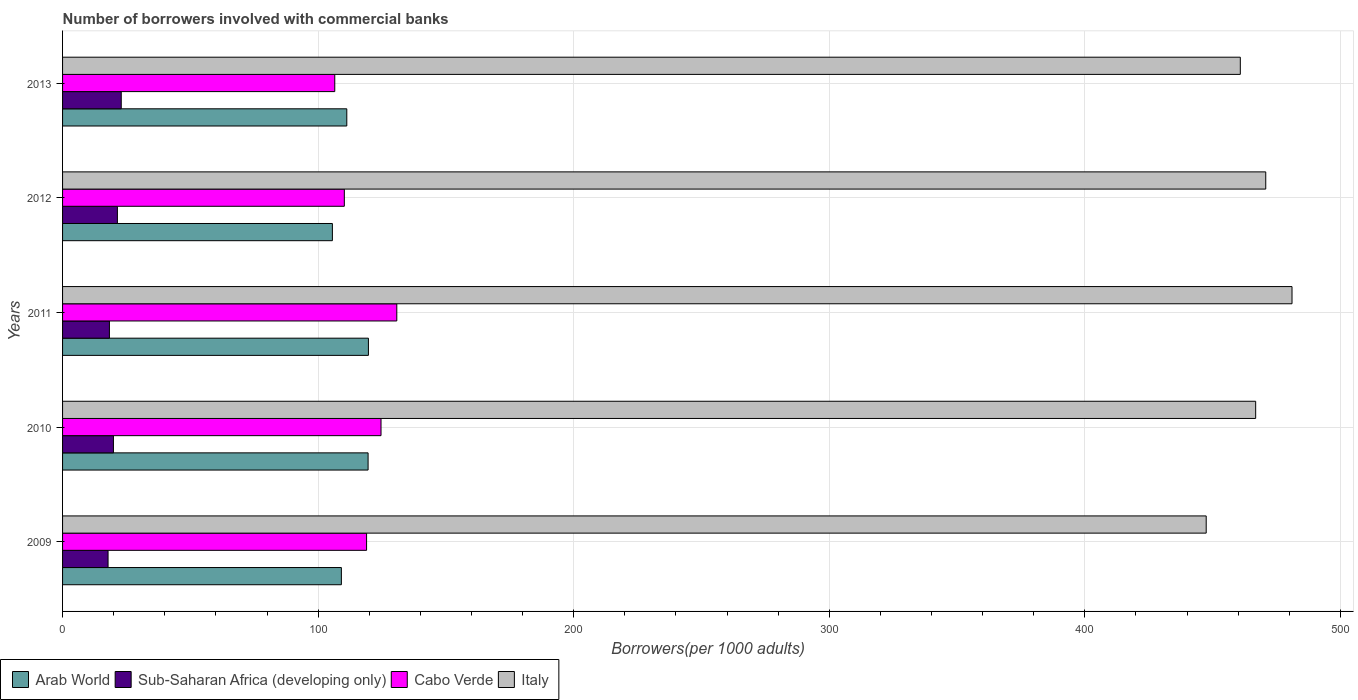How many groups of bars are there?
Ensure brevity in your answer.  5. Are the number of bars on each tick of the Y-axis equal?
Offer a very short reply. Yes. How many bars are there on the 4th tick from the bottom?
Make the answer very short. 4. In how many cases, is the number of bars for a given year not equal to the number of legend labels?
Provide a succinct answer. 0. What is the number of borrowers involved with commercial banks in Italy in 2011?
Provide a succinct answer. 481.07. Across all years, what is the maximum number of borrowers involved with commercial banks in Italy?
Your answer should be very brief. 481.07. Across all years, what is the minimum number of borrowers involved with commercial banks in Cabo Verde?
Provide a short and direct response. 106.51. In which year was the number of borrowers involved with commercial banks in Sub-Saharan Africa (developing only) minimum?
Give a very brief answer. 2009. What is the total number of borrowers involved with commercial banks in Sub-Saharan Africa (developing only) in the graph?
Ensure brevity in your answer.  100.46. What is the difference between the number of borrowers involved with commercial banks in Cabo Verde in 2010 and that in 2011?
Offer a terse response. -6.18. What is the difference between the number of borrowers involved with commercial banks in Sub-Saharan Africa (developing only) in 2009 and the number of borrowers involved with commercial banks in Italy in 2012?
Provide a short and direct response. -452.98. What is the average number of borrowers involved with commercial banks in Arab World per year?
Offer a terse response. 113.02. In the year 2012, what is the difference between the number of borrowers involved with commercial banks in Arab World and number of borrowers involved with commercial banks in Italy?
Give a very brief answer. -365.21. What is the ratio of the number of borrowers involved with commercial banks in Sub-Saharan Africa (developing only) in 2010 to that in 2011?
Keep it short and to the point. 1.09. Is the difference between the number of borrowers involved with commercial banks in Arab World in 2009 and 2012 greater than the difference between the number of borrowers involved with commercial banks in Italy in 2009 and 2012?
Your answer should be compact. Yes. What is the difference between the highest and the second highest number of borrowers involved with commercial banks in Italy?
Give a very brief answer. 10.28. What is the difference between the highest and the lowest number of borrowers involved with commercial banks in Arab World?
Your response must be concise. 14.1. What does the 2nd bar from the top in 2011 represents?
Ensure brevity in your answer.  Cabo Verde. How many bars are there?
Offer a very short reply. 20. Does the graph contain grids?
Give a very brief answer. Yes. How are the legend labels stacked?
Provide a succinct answer. Horizontal. What is the title of the graph?
Your response must be concise. Number of borrowers involved with commercial banks. Does "Botswana" appear as one of the legend labels in the graph?
Offer a very short reply. No. What is the label or title of the X-axis?
Offer a very short reply. Borrowers(per 1000 adults). What is the label or title of the Y-axis?
Offer a terse response. Years. What is the Borrowers(per 1000 adults) of Arab World in 2009?
Offer a terse response. 109.1. What is the Borrowers(per 1000 adults) in Sub-Saharan Africa (developing only) in 2009?
Provide a short and direct response. 17.81. What is the Borrowers(per 1000 adults) of Cabo Verde in 2009?
Provide a short and direct response. 118.96. What is the Borrowers(per 1000 adults) in Italy in 2009?
Offer a very short reply. 447.49. What is the Borrowers(per 1000 adults) of Arab World in 2010?
Keep it short and to the point. 119.55. What is the Borrowers(per 1000 adults) of Sub-Saharan Africa (developing only) in 2010?
Keep it short and to the point. 19.9. What is the Borrowers(per 1000 adults) of Cabo Verde in 2010?
Your answer should be compact. 124.61. What is the Borrowers(per 1000 adults) in Italy in 2010?
Your answer should be very brief. 466.85. What is the Borrowers(per 1000 adults) in Arab World in 2011?
Give a very brief answer. 119.68. What is the Borrowers(per 1000 adults) in Sub-Saharan Africa (developing only) in 2011?
Provide a short and direct response. 18.33. What is the Borrowers(per 1000 adults) in Cabo Verde in 2011?
Make the answer very short. 130.78. What is the Borrowers(per 1000 adults) of Italy in 2011?
Give a very brief answer. 481.07. What is the Borrowers(per 1000 adults) of Arab World in 2012?
Keep it short and to the point. 105.58. What is the Borrowers(per 1000 adults) in Sub-Saharan Africa (developing only) in 2012?
Your answer should be compact. 21.46. What is the Borrowers(per 1000 adults) of Cabo Verde in 2012?
Your answer should be compact. 110.25. What is the Borrowers(per 1000 adults) of Italy in 2012?
Your answer should be very brief. 470.79. What is the Borrowers(per 1000 adults) in Arab World in 2013?
Provide a short and direct response. 111.22. What is the Borrowers(per 1000 adults) of Sub-Saharan Africa (developing only) in 2013?
Make the answer very short. 22.96. What is the Borrowers(per 1000 adults) in Cabo Verde in 2013?
Give a very brief answer. 106.51. What is the Borrowers(per 1000 adults) of Italy in 2013?
Ensure brevity in your answer.  460.84. Across all years, what is the maximum Borrowers(per 1000 adults) in Arab World?
Your answer should be very brief. 119.68. Across all years, what is the maximum Borrowers(per 1000 adults) in Sub-Saharan Africa (developing only)?
Your answer should be very brief. 22.96. Across all years, what is the maximum Borrowers(per 1000 adults) of Cabo Verde?
Your response must be concise. 130.78. Across all years, what is the maximum Borrowers(per 1000 adults) in Italy?
Give a very brief answer. 481.07. Across all years, what is the minimum Borrowers(per 1000 adults) of Arab World?
Ensure brevity in your answer.  105.58. Across all years, what is the minimum Borrowers(per 1000 adults) in Sub-Saharan Africa (developing only)?
Ensure brevity in your answer.  17.81. Across all years, what is the minimum Borrowers(per 1000 adults) of Cabo Verde?
Offer a terse response. 106.51. Across all years, what is the minimum Borrowers(per 1000 adults) of Italy?
Keep it short and to the point. 447.49. What is the total Borrowers(per 1000 adults) in Arab World in the graph?
Provide a succinct answer. 565.12. What is the total Borrowers(per 1000 adults) of Sub-Saharan Africa (developing only) in the graph?
Provide a succinct answer. 100.46. What is the total Borrowers(per 1000 adults) of Cabo Verde in the graph?
Give a very brief answer. 591.11. What is the total Borrowers(per 1000 adults) of Italy in the graph?
Your answer should be very brief. 2327.04. What is the difference between the Borrowers(per 1000 adults) of Arab World in 2009 and that in 2010?
Keep it short and to the point. -10.45. What is the difference between the Borrowers(per 1000 adults) in Sub-Saharan Africa (developing only) in 2009 and that in 2010?
Keep it short and to the point. -2.1. What is the difference between the Borrowers(per 1000 adults) of Cabo Verde in 2009 and that in 2010?
Make the answer very short. -5.65. What is the difference between the Borrowers(per 1000 adults) in Italy in 2009 and that in 2010?
Your response must be concise. -19.36. What is the difference between the Borrowers(per 1000 adults) of Arab World in 2009 and that in 2011?
Your answer should be very brief. -10.58. What is the difference between the Borrowers(per 1000 adults) of Sub-Saharan Africa (developing only) in 2009 and that in 2011?
Your response must be concise. -0.53. What is the difference between the Borrowers(per 1000 adults) of Cabo Verde in 2009 and that in 2011?
Your answer should be compact. -11.82. What is the difference between the Borrowers(per 1000 adults) in Italy in 2009 and that in 2011?
Make the answer very short. -33.58. What is the difference between the Borrowers(per 1000 adults) of Arab World in 2009 and that in 2012?
Keep it short and to the point. 3.52. What is the difference between the Borrowers(per 1000 adults) of Sub-Saharan Africa (developing only) in 2009 and that in 2012?
Keep it short and to the point. -3.65. What is the difference between the Borrowers(per 1000 adults) of Cabo Verde in 2009 and that in 2012?
Ensure brevity in your answer.  8.71. What is the difference between the Borrowers(per 1000 adults) of Italy in 2009 and that in 2012?
Give a very brief answer. -23.3. What is the difference between the Borrowers(per 1000 adults) of Arab World in 2009 and that in 2013?
Provide a short and direct response. -2.12. What is the difference between the Borrowers(per 1000 adults) of Sub-Saharan Africa (developing only) in 2009 and that in 2013?
Keep it short and to the point. -5.16. What is the difference between the Borrowers(per 1000 adults) of Cabo Verde in 2009 and that in 2013?
Provide a short and direct response. 12.45. What is the difference between the Borrowers(per 1000 adults) in Italy in 2009 and that in 2013?
Ensure brevity in your answer.  -13.35. What is the difference between the Borrowers(per 1000 adults) of Arab World in 2010 and that in 2011?
Keep it short and to the point. -0.13. What is the difference between the Borrowers(per 1000 adults) in Sub-Saharan Africa (developing only) in 2010 and that in 2011?
Offer a very short reply. 1.57. What is the difference between the Borrowers(per 1000 adults) of Cabo Verde in 2010 and that in 2011?
Your answer should be compact. -6.18. What is the difference between the Borrowers(per 1000 adults) of Italy in 2010 and that in 2011?
Offer a terse response. -14.22. What is the difference between the Borrowers(per 1000 adults) in Arab World in 2010 and that in 2012?
Your response must be concise. 13.97. What is the difference between the Borrowers(per 1000 adults) in Sub-Saharan Africa (developing only) in 2010 and that in 2012?
Provide a succinct answer. -1.56. What is the difference between the Borrowers(per 1000 adults) of Cabo Verde in 2010 and that in 2012?
Keep it short and to the point. 14.36. What is the difference between the Borrowers(per 1000 adults) of Italy in 2010 and that in 2012?
Offer a terse response. -3.94. What is the difference between the Borrowers(per 1000 adults) of Arab World in 2010 and that in 2013?
Make the answer very short. 8.33. What is the difference between the Borrowers(per 1000 adults) in Sub-Saharan Africa (developing only) in 2010 and that in 2013?
Keep it short and to the point. -3.06. What is the difference between the Borrowers(per 1000 adults) in Cabo Verde in 2010 and that in 2013?
Make the answer very short. 18.1. What is the difference between the Borrowers(per 1000 adults) in Italy in 2010 and that in 2013?
Your answer should be compact. 6.01. What is the difference between the Borrowers(per 1000 adults) of Arab World in 2011 and that in 2012?
Keep it short and to the point. 14.1. What is the difference between the Borrowers(per 1000 adults) in Sub-Saharan Africa (developing only) in 2011 and that in 2012?
Your answer should be very brief. -3.13. What is the difference between the Borrowers(per 1000 adults) in Cabo Verde in 2011 and that in 2012?
Ensure brevity in your answer.  20.53. What is the difference between the Borrowers(per 1000 adults) of Italy in 2011 and that in 2012?
Give a very brief answer. 10.28. What is the difference between the Borrowers(per 1000 adults) in Arab World in 2011 and that in 2013?
Offer a terse response. 8.46. What is the difference between the Borrowers(per 1000 adults) of Sub-Saharan Africa (developing only) in 2011 and that in 2013?
Provide a succinct answer. -4.63. What is the difference between the Borrowers(per 1000 adults) of Cabo Verde in 2011 and that in 2013?
Your answer should be very brief. 24.27. What is the difference between the Borrowers(per 1000 adults) in Italy in 2011 and that in 2013?
Provide a short and direct response. 20.23. What is the difference between the Borrowers(per 1000 adults) in Arab World in 2012 and that in 2013?
Keep it short and to the point. -5.64. What is the difference between the Borrowers(per 1000 adults) in Sub-Saharan Africa (developing only) in 2012 and that in 2013?
Your answer should be compact. -1.5. What is the difference between the Borrowers(per 1000 adults) in Cabo Verde in 2012 and that in 2013?
Make the answer very short. 3.74. What is the difference between the Borrowers(per 1000 adults) of Italy in 2012 and that in 2013?
Offer a terse response. 9.95. What is the difference between the Borrowers(per 1000 adults) of Arab World in 2009 and the Borrowers(per 1000 adults) of Sub-Saharan Africa (developing only) in 2010?
Give a very brief answer. 89.19. What is the difference between the Borrowers(per 1000 adults) in Arab World in 2009 and the Borrowers(per 1000 adults) in Cabo Verde in 2010?
Offer a terse response. -15.51. What is the difference between the Borrowers(per 1000 adults) of Arab World in 2009 and the Borrowers(per 1000 adults) of Italy in 2010?
Your answer should be very brief. -357.75. What is the difference between the Borrowers(per 1000 adults) of Sub-Saharan Africa (developing only) in 2009 and the Borrowers(per 1000 adults) of Cabo Verde in 2010?
Provide a short and direct response. -106.8. What is the difference between the Borrowers(per 1000 adults) of Sub-Saharan Africa (developing only) in 2009 and the Borrowers(per 1000 adults) of Italy in 2010?
Provide a short and direct response. -449.05. What is the difference between the Borrowers(per 1000 adults) of Cabo Verde in 2009 and the Borrowers(per 1000 adults) of Italy in 2010?
Ensure brevity in your answer.  -347.89. What is the difference between the Borrowers(per 1000 adults) in Arab World in 2009 and the Borrowers(per 1000 adults) in Sub-Saharan Africa (developing only) in 2011?
Your answer should be very brief. 90.77. What is the difference between the Borrowers(per 1000 adults) in Arab World in 2009 and the Borrowers(per 1000 adults) in Cabo Verde in 2011?
Give a very brief answer. -21.69. What is the difference between the Borrowers(per 1000 adults) in Arab World in 2009 and the Borrowers(per 1000 adults) in Italy in 2011?
Provide a short and direct response. -371.97. What is the difference between the Borrowers(per 1000 adults) of Sub-Saharan Africa (developing only) in 2009 and the Borrowers(per 1000 adults) of Cabo Verde in 2011?
Offer a terse response. -112.98. What is the difference between the Borrowers(per 1000 adults) in Sub-Saharan Africa (developing only) in 2009 and the Borrowers(per 1000 adults) in Italy in 2011?
Offer a terse response. -463.27. What is the difference between the Borrowers(per 1000 adults) of Cabo Verde in 2009 and the Borrowers(per 1000 adults) of Italy in 2011?
Provide a succinct answer. -362.11. What is the difference between the Borrowers(per 1000 adults) in Arab World in 2009 and the Borrowers(per 1000 adults) in Sub-Saharan Africa (developing only) in 2012?
Your answer should be very brief. 87.64. What is the difference between the Borrowers(per 1000 adults) in Arab World in 2009 and the Borrowers(per 1000 adults) in Cabo Verde in 2012?
Give a very brief answer. -1.15. What is the difference between the Borrowers(per 1000 adults) of Arab World in 2009 and the Borrowers(per 1000 adults) of Italy in 2012?
Your answer should be very brief. -361.69. What is the difference between the Borrowers(per 1000 adults) in Sub-Saharan Africa (developing only) in 2009 and the Borrowers(per 1000 adults) in Cabo Verde in 2012?
Ensure brevity in your answer.  -92.45. What is the difference between the Borrowers(per 1000 adults) of Sub-Saharan Africa (developing only) in 2009 and the Borrowers(per 1000 adults) of Italy in 2012?
Give a very brief answer. -452.98. What is the difference between the Borrowers(per 1000 adults) in Cabo Verde in 2009 and the Borrowers(per 1000 adults) in Italy in 2012?
Give a very brief answer. -351.83. What is the difference between the Borrowers(per 1000 adults) in Arab World in 2009 and the Borrowers(per 1000 adults) in Sub-Saharan Africa (developing only) in 2013?
Make the answer very short. 86.13. What is the difference between the Borrowers(per 1000 adults) in Arab World in 2009 and the Borrowers(per 1000 adults) in Cabo Verde in 2013?
Give a very brief answer. 2.59. What is the difference between the Borrowers(per 1000 adults) of Arab World in 2009 and the Borrowers(per 1000 adults) of Italy in 2013?
Keep it short and to the point. -351.74. What is the difference between the Borrowers(per 1000 adults) of Sub-Saharan Africa (developing only) in 2009 and the Borrowers(per 1000 adults) of Cabo Verde in 2013?
Provide a short and direct response. -88.7. What is the difference between the Borrowers(per 1000 adults) of Sub-Saharan Africa (developing only) in 2009 and the Borrowers(per 1000 adults) of Italy in 2013?
Keep it short and to the point. -443.04. What is the difference between the Borrowers(per 1000 adults) of Cabo Verde in 2009 and the Borrowers(per 1000 adults) of Italy in 2013?
Make the answer very short. -341.88. What is the difference between the Borrowers(per 1000 adults) of Arab World in 2010 and the Borrowers(per 1000 adults) of Sub-Saharan Africa (developing only) in 2011?
Keep it short and to the point. 101.22. What is the difference between the Borrowers(per 1000 adults) of Arab World in 2010 and the Borrowers(per 1000 adults) of Cabo Verde in 2011?
Your answer should be compact. -11.23. What is the difference between the Borrowers(per 1000 adults) of Arab World in 2010 and the Borrowers(per 1000 adults) of Italy in 2011?
Provide a succinct answer. -361.52. What is the difference between the Borrowers(per 1000 adults) in Sub-Saharan Africa (developing only) in 2010 and the Borrowers(per 1000 adults) in Cabo Verde in 2011?
Ensure brevity in your answer.  -110.88. What is the difference between the Borrowers(per 1000 adults) in Sub-Saharan Africa (developing only) in 2010 and the Borrowers(per 1000 adults) in Italy in 2011?
Offer a terse response. -461.17. What is the difference between the Borrowers(per 1000 adults) in Cabo Verde in 2010 and the Borrowers(per 1000 adults) in Italy in 2011?
Give a very brief answer. -356.46. What is the difference between the Borrowers(per 1000 adults) of Arab World in 2010 and the Borrowers(per 1000 adults) of Sub-Saharan Africa (developing only) in 2012?
Give a very brief answer. 98.09. What is the difference between the Borrowers(per 1000 adults) of Arab World in 2010 and the Borrowers(per 1000 adults) of Cabo Verde in 2012?
Offer a very short reply. 9.3. What is the difference between the Borrowers(per 1000 adults) in Arab World in 2010 and the Borrowers(per 1000 adults) in Italy in 2012?
Keep it short and to the point. -351.24. What is the difference between the Borrowers(per 1000 adults) of Sub-Saharan Africa (developing only) in 2010 and the Borrowers(per 1000 adults) of Cabo Verde in 2012?
Provide a short and direct response. -90.35. What is the difference between the Borrowers(per 1000 adults) of Sub-Saharan Africa (developing only) in 2010 and the Borrowers(per 1000 adults) of Italy in 2012?
Your answer should be very brief. -450.89. What is the difference between the Borrowers(per 1000 adults) in Cabo Verde in 2010 and the Borrowers(per 1000 adults) in Italy in 2012?
Offer a terse response. -346.18. What is the difference between the Borrowers(per 1000 adults) in Arab World in 2010 and the Borrowers(per 1000 adults) in Sub-Saharan Africa (developing only) in 2013?
Your answer should be very brief. 96.59. What is the difference between the Borrowers(per 1000 adults) of Arab World in 2010 and the Borrowers(per 1000 adults) of Cabo Verde in 2013?
Make the answer very short. 13.04. What is the difference between the Borrowers(per 1000 adults) in Arab World in 2010 and the Borrowers(per 1000 adults) in Italy in 2013?
Provide a succinct answer. -341.29. What is the difference between the Borrowers(per 1000 adults) in Sub-Saharan Africa (developing only) in 2010 and the Borrowers(per 1000 adults) in Cabo Verde in 2013?
Your answer should be compact. -86.6. What is the difference between the Borrowers(per 1000 adults) in Sub-Saharan Africa (developing only) in 2010 and the Borrowers(per 1000 adults) in Italy in 2013?
Provide a succinct answer. -440.94. What is the difference between the Borrowers(per 1000 adults) of Cabo Verde in 2010 and the Borrowers(per 1000 adults) of Italy in 2013?
Your answer should be compact. -336.23. What is the difference between the Borrowers(per 1000 adults) of Arab World in 2011 and the Borrowers(per 1000 adults) of Sub-Saharan Africa (developing only) in 2012?
Keep it short and to the point. 98.22. What is the difference between the Borrowers(per 1000 adults) of Arab World in 2011 and the Borrowers(per 1000 adults) of Cabo Verde in 2012?
Provide a short and direct response. 9.43. What is the difference between the Borrowers(per 1000 adults) of Arab World in 2011 and the Borrowers(per 1000 adults) of Italy in 2012?
Keep it short and to the point. -351.11. What is the difference between the Borrowers(per 1000 adults) of Sub-Saharan Africa (developing only) in 2011 and the Borrowers(per 1000 adults) of Cabo Verde in 2012?
Make the answer very short. -91.92. What is the difference between the Borrowers(per 1000 adults) in Sub-Saharan Africa (developing only) in 2011 and the Borrowers(per 1000 adults) in Italy in 2012?
Offer a terse response. -452.46. What is the difference between the Borrowers(per 1000 adults) of Cabo Verde in 2011 and the Borrowers(per 1000 adults) of Italy in 2012?
Provide a short and direct response. -340.01. What is the difference between the Borrowers(per 1000 adults) in Arab World in 2011 and the Borrowers(per 1000 adults) in Sub-Saharan Africa (developing only) in 2013?
Offer a very short reply. 96.72. What is the difference between the Borrowers(per 1000 adults) in Arab World in 2011 and the Borrowers(per 1000 adults) in Cabo Verde in 2013?
Give a very brief answer. 13.17. What is the difference between the Borrowers(per 1000 adults) of Arab World in 2011 and the Borrowers(per 1000 adults) of Italy in 2013?
Your answer should be compact. -341.16. What is the difference between the Borrowers(per 1000 adults) of Sub-Saharan Africa (developing only) in 2011 and the Borrowers(per 1000 adults) of Cabo Verde in 2013?
Keep it short and to the point. -88.18. What is the difference between the Borrowers(per 1000 adults) in Sub-Saharan Africa (developing only) in 2011 and the Borrowers(per 1000 adults) in Italy in 2013?
Ensure brevity in your answer.  -442.51. What is the difference between the Borrowers(per 1000 adults) of Cabo Verde in 2011 and the Borrowers(per 1000 adults) of Italy in 2013?
Ensure brevity in your answer.  -330.06. What is the difference between the Borrowers(per 1000 adults) of Arab World in 2012 and the Borrowers(per 1000 adults) of Sub-Saharan Africa (developing only) in 2013?
Make the answer very short. 82.62. What is the difference between the Borrowers(per 1000 adults) of Arab World in 2012 and the Borrowers(per 1000 adults) of Cabo Verde in 2013?
Offer a terse response. -0.93. What is the difference between the Borrowers(per 1000 adults) in Arab World in 2012 and the Borrowers(per 1000 adults) in Italy in 2013?
Provide a succinct answer. -355.26. What is the difference between the Borrowers(per 1000 adults) of Sub-Saharan Africa (developing only) in 2012 and the Borrowers(per 1000 adults) of Cabo Verde in 2013?
Your answer should be very brief. -85.05. What is the difference between the Borrowers(per 1000 adults) in Sub-Saharan Africa (developing only) in 2012 and the Borrowers(per 1000 adults) in Italy in 2013?
Your response must be concise. -439.38. What is the difference between the Borrowers(per 1000 adults) in Cabo Verde in 2012 and the Borrowers(per 1000 adults) in Italy in 2013?
Your answer should be very brief. -350.59. What is the average Borrowers(per 1000 adults) of Arab World per year?
Offer a terse response. 113.02. What is the average Borrowers(per 1000 adults) of Sub-Saharan Africa (developing only) per year?
Make the answer very short. 20.09. What is the average Borrowers(per 1000 adults) in Cabo Verde per year?
Give a very brief answer. 118.22. What is the average Borrowers(per 1000 adults) of Italy per year?
Your response must be concise. 465.41. In the year 2009, what is the difference between the Borrowers(per 1000 adults) in Arab World and Borrowers(per 1000 adults) in Sub-Saharan Africa (developing only)?
Provide a short and direct response. 91.29. In the year 2009, what is the difference between the Borrowers(per 1000 adults) of Arab World and Borrowers(per 1000 adults) of Cabo Verde?
Offer a terse response. -9.86. In the year 2009, what is the difference between the Borrowers(per 1000 adults) in Arab World and Borrowers(per 1000 adults) in Italy?
Provide a short and direct response. -338.39. In the year 2009, what is the difference between the Borrowers(per 1000 adults) in Sub-Saharan Africa (developing only) and Borrowers(per 1000 adults) in Cabo Verde?
Your answer should be very brief. -101.15. In the year 2009, what is the difference between the Borrowers(per 1000 adults) of Sub-Saharan Africa (developing only) and Borrowers(per 1000 adults) of Italy?
Keep it short and to the point. -429.68. In the year 2009, what is the difference between the Borrowers(per 1000 adults) in Cabo Verde and Borrowers(per 1000 adults) in Italy?
Offer a very short reply. -328.53. In the year 2010, what is the difference between the Borrowers(per 1000 adults) in Arab World and Borrowers(per 1000 adults) in Sub-Saharan Africa (developing only)?
Your response must be concise. 99.65. In the year 2010, what is the difference between the Borrowers(per 1000 adults) in Arab World and Borrowers(per 1000 adults) in Cabo Verde?
Offer a very short reply. -5.06. In the year 2010, what is the difference between the Borrowers(per 1000 adults) in Arab World and Borrowers(per 1000 adults) in Italy?
Ensure brevity in your answer.  -347.3. In the year 2010, what is the difference between the Borrowers(per 1000 adults) in Sub-Saharan Africa (developing only) and Borrowers(per 1000 adults) in Cabo Verde?
Provide a short and direct response. -104.7. In the year 2010, what is the difference between the Borrowers(per 1000 adults) in Sub-Saharan Africa (developing only) and Borrowers(per 1000 adults) in Italy?
Your response must be concise. -446.95. In the year 2010, what is the difference between the Borrowers(per 1000 adults) in Cabo Verde and Borrowers(per 1000 adults) in Italy?
Ensure brevity in your answer.  -342.24. In the year 2011, what is the difference between the Borrowers(per 1000 adults) in Arab World and Borrowers(per 1000 adults) in Sub-Saharan Africa (developing only)?
Ensure brevity in your answer.  101.35. In the year 2011, what is the difference between the Borrowers(per 1000 adults) in Arab World and Borrowers(per 1000 adults) in Cabo Verde?
Your answer should be very brief. -11.1. In the year 2011, what is the difference between the Borrowers(per 1000 adults) in Arab World and Borrowers(per 1000 adults) in Italy?
Your response must be concise. -361.39. In the year 2011, what is the difference between the Borrowers(per 1000 adults) in Sub-Saharan Africa (developing only) and Borrowers(per 1000 adults) in Cabo Verde?
Make the answer very short. -112.45. In the year 2011, what is the difference between the Borrowers(per 1000 adults) in Sub-Saharan Africa (developing only) and Borrowers(per 1000 adults) in Italy?
Ensure brevity in your answer.  -462.74. In the year 2011, what is the difference between the Borrowers(per 1000 adults) in Cabo Verde and Borrowers(per 1000 adults) in Italy?
Your response must be concise. -350.29. In the year 2012, what is the difference between the Borrowers(per 1000 adults) of Arab World and Borrowers(per 1000 adults) of Sub-Saharan Africa (developing only)?
Make the answer very short. 84.12. In the year 2012, what is the difference between the Borrowers(per 1000 adults) in Arab World and Borrowers(per 1000 adults) in Cabo Verde?
Keep it short and to the point. -4.67. In the year 2012, what is the difference between the Borrowers(per 1000 adults) in Arab World and Borrowers(per 1000 adults) in Italy?
Your answer should be very brief. -365.21. In the year 2012, what is the difference between the Borrowers(per 1000 adults) in Sub-Saharan Africa (developing only) and Borrowers(per 1000 adults) in Cabo Verde?
Offer a terse response. -88.79. In the year 2012, what is the difference between the Borrowers(per 1000 adults) in Sub-Saharan Africa (developing only) and Borrowers(per 1000 adults) in Italy?
Your response must be concise. -449.33. In the year 2012, what is the difference between the Borrowers(per 1000 adults) in Cabo Verde and Borrowers(per 1000 adults) in Italy?
Offer a terse response. -360.54. In the year 2013, what is the difference between the Borrowers(per 1000 adults) of Arab World and Borrowers(per 1000 adults) of Sub-Saharan Africa (developing only)?
Keep it short and to the point. 88.25. In the year 2013, what is the difference between the Borrowers(per 1000 adults) in Arab World and Borrowers(per 1000 adults) in Cabo Verde?
Your response must be concise. 4.71. In the year 2013, what is the difference between the Borrowers(per 1000 adults) of Arab World and Borrowers(per 1000 adults) of Italy?
Give a very brief answer. -349.62. In the year 2013, what is the difference between the Borrowers(per 1000 adults) of Sub-Saharan Africa (developing only) and Borrowers(per 1000 adults) of Cabo Verde?
Give a very brief answer. -83.55. In the year 2013, what is the difference between the Borrowers(per 1000 adults) in Sub-Saharan Africa (developing only) and Borrowers(per 1000 adults) in Italy?
Provide a short and direct response. -437.88. In the year 2013, what is the difference between the Borrowers(per 1000 adults) in Cabo Verde and Borrowers(per 1000 adults) in Italy?
Your answer should be compact. -354.33. What is the ratio of the Borrowers(per 1000 adults) in Arab World in 2009 to that in 2010?
Your response must be concise. 0.91. What is the ratio of the Borrowers(per 1000 adults) of Sub-Saharan Africa (developing only) in 2009 to that in 2010?
Offer a terse response. 0.89. What is the ratio of the Borrowers(per 1000 adults) of Cabo Verde in 2009 to that in 2010?
Make the answer very short. 0.95. What is the ratio of the Borrowers(per 1000 adults) in Italy in 2009 to that in 2010?
Make the answer very short. 0.96. What is the ratio of the Borrowers(per 1000 adults) of Arab World in 2009 to that in 2011?
Your response must be concise. 0.91. What is the ratio of the Borrowers(per 1000 adults) of Sub-Saharan Africa (developing only) in 2009 to that in 2011?
Provide a succinct answer. 0.97. What is the ratio of the Borrowers(per 1000 adults) of Cabo Verde in 2009 to that in 2011?
Offer a terse response. 0.91. What is the ratio of the Borrowers(per 1000 adults) in Italy in 2009 to that in 2011?
Provide a short and direct response. 0.93. What is the ratio of the Borrowers(per 1000 adults) in Sub-Saharan Africa (developing only) in 2009 to that in 2012?
Keep it short and to the point. 0.83. What is the ratio of the Borrowers(per 1000 adults) in Cabo Verde in 2009 to that in 2012?
Keep it short and to the point. 1.08. What is the ratio of the Borrowers(per 1000 adults) of Italy in 2009 to that in 2012?
Give a very brief answer. 0.95. What is the ratio of the Borrowers(per 1000 adults) in Arab World in 2009 to that in 2013?
Your answer should be very brief. 0.98. What is the ratio of the Borrowers(per 1000 adults) in Sub-Saharan Africa (developing only) in 2009 to that in 2013?
Ensure brevity in your answer.  0.78. What is the ratio of the Borrowers(per 1000 adults) of Cabo Verde in 2009 to that in 2013?
Keep it short and to the point. 1.12. What is the ratio of the Borrowers(per 1000 adults) of Arab World in 2010 to that in 2011?
Ensure brevity in your answer.  1. What is the ratio of the Borrowers(per 1000 adults) of Sub-Saharan Africa (developing only) in 2010 to that in 2011?
Provide a short and direct response. 1.09. What is the ratio of the Borrowers(per 1000 adults) of Cabo Verde in 2010 to that in 2011?
Give a very brief answer. 0.95. What is the ratio of the Borrowers(per 1000 adults) of Italy in 2010 to that in 2011?
Your answer should be compact. 0.97. What is the ratio of the Borrowers(per 1000 adults) in Arab World in 2010 to that in 2012?
Offer a terse response. 1.13. What is the ratio of the Borrowers(per 1000 adults) of Sub-Saharan Africa (developing only) in 2010 to that in 2012?
Offer a very short reply. 0.93. What is the ratio of the Borrowers(per 1000 adults) of Cabo Verde in 2010 to that in 2012?
Your response must be concise. 1.13. What is the ratio of the Borrowers(per 1000 adults) in Italy in 2010 to that in 2012?
Make the answer very short. 0.99. What is the ratio of the Borrowers(per 1000 adults) of Arab World in 2010 to that in 2013?
Your response must be concise. 1.07. What is the ratio of the Borrowers(per 1000 adults) of Sub-Saharan Africa (developing only) in 2010 to that in 2013?
Offer a terse response. 0.87. What is the ratio of the Borrowers(per 1000 adults) in Cabo Verde in 2010 to that in 2013?
Ensure brevity in your answer.  1.17. What is the ratio of the Borrowers(per 1000 adults) in Arab World in 2011 to that in 2012?
Keep it short and to the point. 1.13. What is the ratio of the Borrowers(per 1000 adults) of Sub-Saharan Africa (developing only) in 2011 to that in 2012?
Ensure brevity in your answer.  0.85. What is the ratio of the Borrowers(per 1000 adults) of Cabo Verde in 2011 to that in 2012?
Keep it short and to the point. 1.19. What is the ratio of the Borrowers(per 1000 adults) in Italy in 2011 to that in 2012?
Offer a terse response. 1.02. What is the ratio of the Borrowers(per 1000 adults) of Arab World in 2011 to that in 2013?
Provide a short and direct response. 1.08. What is the ratio of the Borrowers(per 1000 adults) of Sub-Saharan Africa (developing only) in 2011 to that in 2013?
Offer a terse response. 0.8. What is the ratio of the Borrowers(per 1000 adults) of Cabo Verde in 2011 to that in 2013?
Your answer should be compact. 1.23. What is the ratio of the Borrowers(per 1000 adults) of Italy in 2011 to that in 2013?
Give a very brief answer. 1.04. What is the ratio of the Borrowers(per 1000 adults) in Arab World in 2012 to that in 2013?
Keep it short and to the point. 0.95. What is the ratio of the Borrowers(per 1000 adults) in Sub-Saharan Africa (developing only) in 2012 to that in 2013?
Make the answer very short. 0.93. What is the ratio of the Borrowers(per 1000 adults) in Cabo Verde in 2012 to that in 2013?
Make the answer very short. 1.04. What is the ratio of the Borrowers(per 1000 adults) in Italy in 2012 to that in 2013?
Offer a very short reply. 1.02. What is the difference between the highest and the second highest Borrowers(per 1000 adults) in Arab World?
Provide a succinct answer. 0.13. What is the difference between the highest and the second highest Borrowers(per 1000 adults) of Sub-Saharan Africa (developing only)?
Offer a terse response. 1.5. What is the difference between the highest and the second highest Borrowers(per 1000 adults) in Cabo Verde?
Your response must be concise. 6.18. What is the difference between the highest and the second highest Borrowers(per 1000 adults) in Italy?
Offer a terse response. 10.28. What is the difference between the highest and the lowest Borrowers(per 1000 adults) in Arab World?
Give a very brief answer. 14.1. What is the difference between the highest and the lowest Borrowers(per 1000 adults) of Sub-Saharan Africa (developing only)?
Give a very brief answer. 5.16. What is the difference between the highest and the lowest Borrowers(per 1000 adults) in Cabo Verde?
Offer a terse response. 24.27. What is the difference between the highest and the lowest Borrowers(per 1000 adults) of Italy?
Make the answer very short. 33.58. 